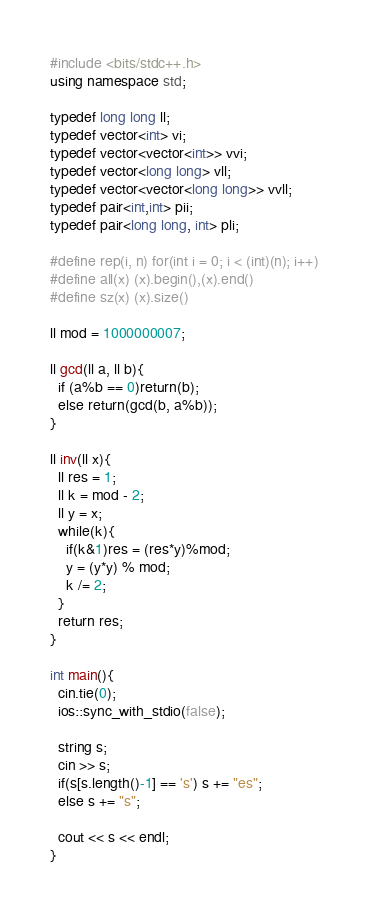<code> <loc_0><loc_0><loc_500><loc_500><_C++_>#include <bits/stdc++.h>
using namespace std;

typedef long long ll;
typedef vector<int> vi;
typedef vector<vector<int>> vvi;
typedef vector<long long> vll;
typedef vector<vector<long long>> vvll;
typedef pair<int,int> pii;
typedef pair<long long, int> pli;

#define rep(i, n) for(int i = 0; i < (int)(n); i++)
#define all(x) (x).begin(),(x).end()
#define sz(x) (x).size()

ll mod = 1000000007;

ll gcd(ll a, ll b){
  if (a%b == 0)return(b);
  else return(gcd(b, a%b));
}

ll inv(ll x){
  ll res = 1;
  ll k = mod - 2;
  ll y = x;
  while(k){
    if(k&1)res = (res*y)%mod;
    y = (y*y) % mod;
    k /= 2;
  }
  return res;
}

int main(){
  cin.tie(0);
  ios::sync_with_stdio(false);

  string s;
  cin >> s;
  if(s[s.length()-1] == 's') s += "es";
  else s += "s";

  cout << s << endl;
}</code> 